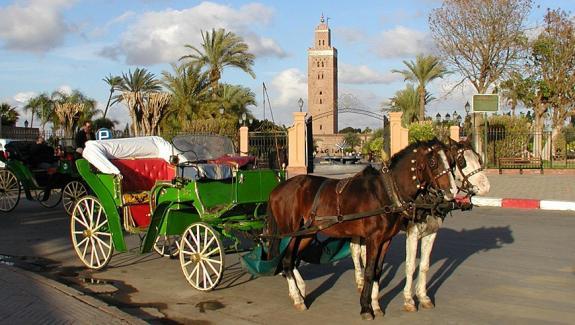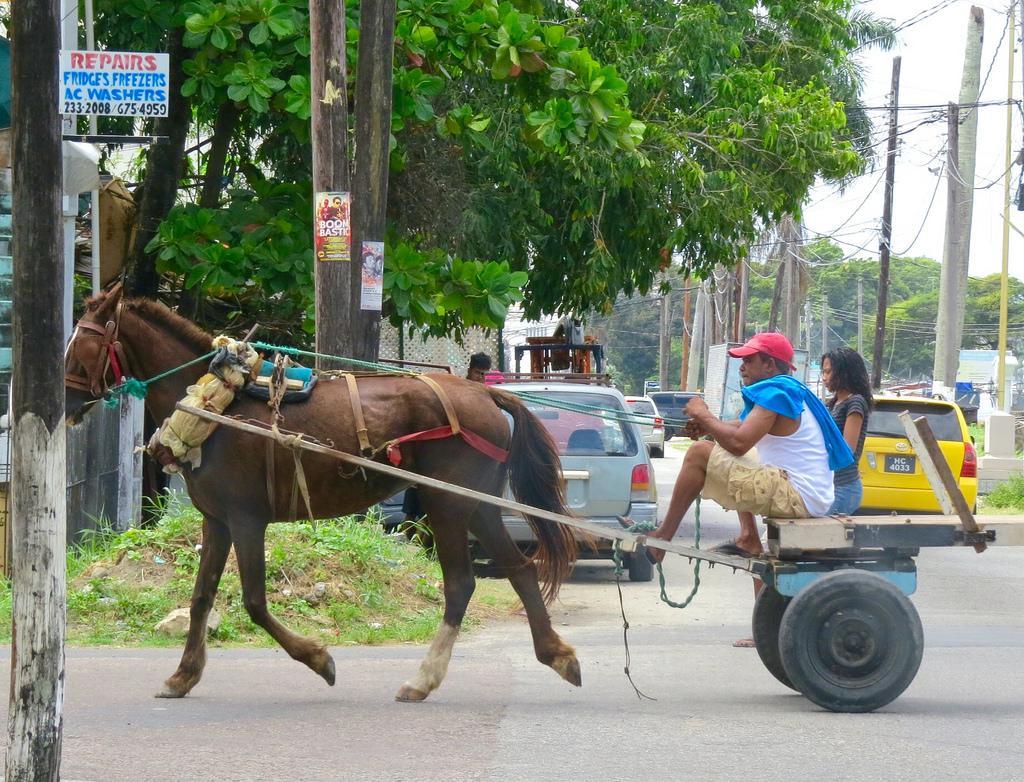The first image is the image on the left, the second image is the image on the right. For the images displayed, is the sentence "The right image shows one animal pulling a wagon with four wheels in a leftward direction." factually correct? Answer yes or no. No. The first image is the image on the left, the second image is the image on the right. For the images displayed, is the sentence "The left and right image contains the same number of mules pulling a cart with at least on being a donkey." factually correct? Answer yes or no. No. 